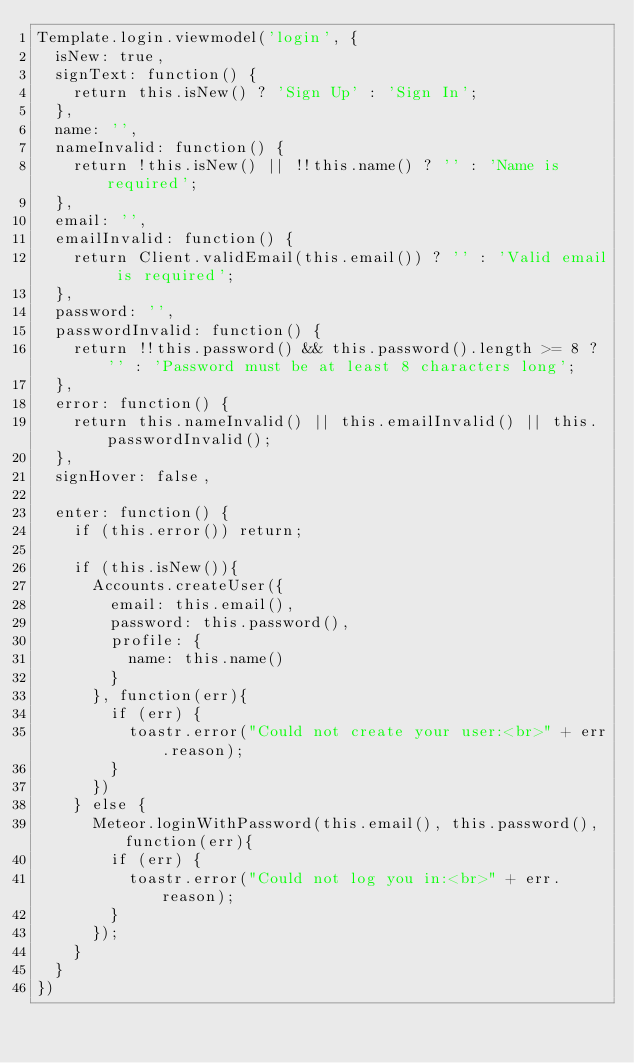Convert code to text. <code><loc_0><loc_0><loc_500><loc_500><_JavaScript_>Template.login.viewmodel('login', {
  isNew: true,
  signText: function() {
    return this.isNew() ? 'Sign Up' : 'Sign In';
  },
  name: '',
  nameInvalid: function() {
    return !this.isNew() || !!this.name() ? '' : 'Name is required';
  },
  email: '',
  emailInvalid: function() {
    return Client.validEmail(this.email()) ? '' : 'Valid email is required';
  },
  password: '',
  passwordInvalid: function() {
    return !!this.password() && this.password().length >= 8 ? '' : 'Password must be at least 8 characters long';
  },
  error: function() {
    return this.nameInvalid() || this.emailInvalid() || this.passwordInvalid();
  },
  signHover: false,

  enter: function() {
    if (this.error()) return;

    if (this.isNew()){
      Accounts.createUser({
        email: this.email(),
        password: this.password(),
        profile: {
          name: this.name()
        }
      }, function(err){
        if (err) {
          toastr.error("Could not create your user:<br>" + err.reason);
        }
      })
    } else {
      Meteor.loginWithPassword(this.email(), this.password(), function(err){
        if (err) {
          toastr.error("Could not log you in:<br>" + err.reason);
        }
      });
    }
  }
})</code> 